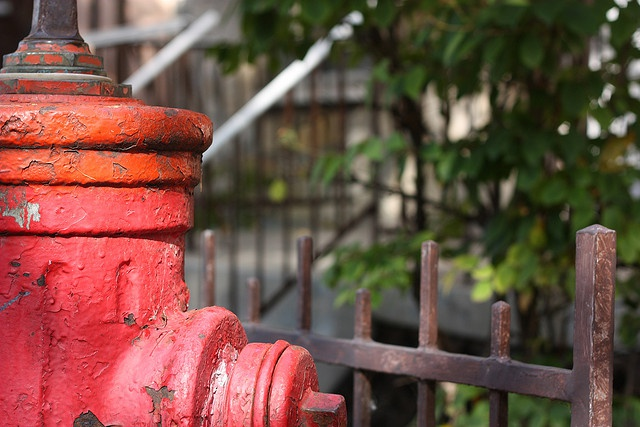Describe the objects in this image and their specific colors. I can see a fire hydrant in black, salmon, lightpink, brown, and red tones in this image. 